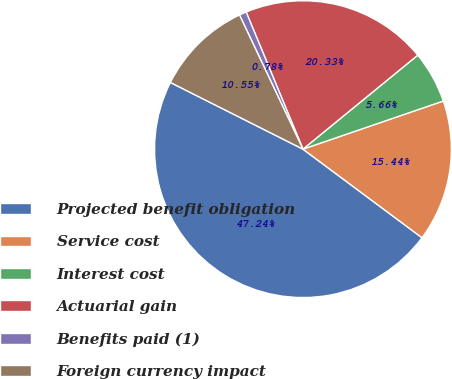Convert chart. <chart><loc_0><loc_0><loc_500><loc_500><pie_chart><fcel>Projected benefit obligation<fcel>Service cost<fcel>Interest cost<fcel>Actuarial gain<fcel>Benefits paid (1)<fcel>Foreign currency impact<nl><fcel>47.24%<fcel>15.44%<fcel>5.66%<fcel>20.33%<fcel>0.78%<fcel>10.55%<nl></chart> 